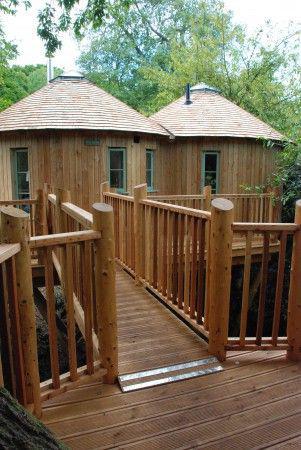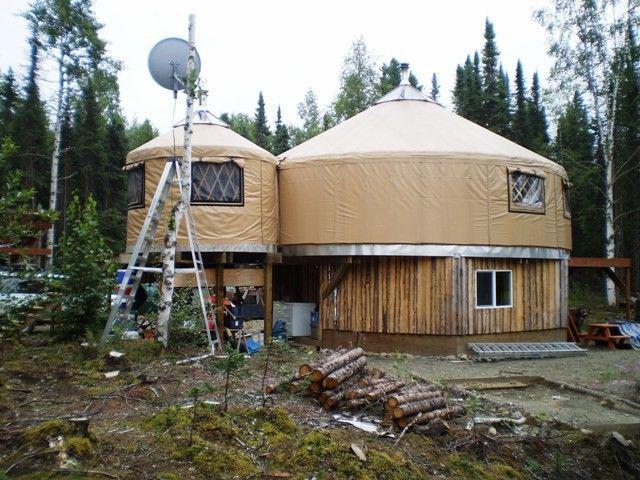The first image is the image on the left, the second image is the image on the right. Examine the images to the left and right. Is the description "Each image shows the exterior of one yurt, featuring some type of wood deck and railing." accurate? Answer yes or no. No. 